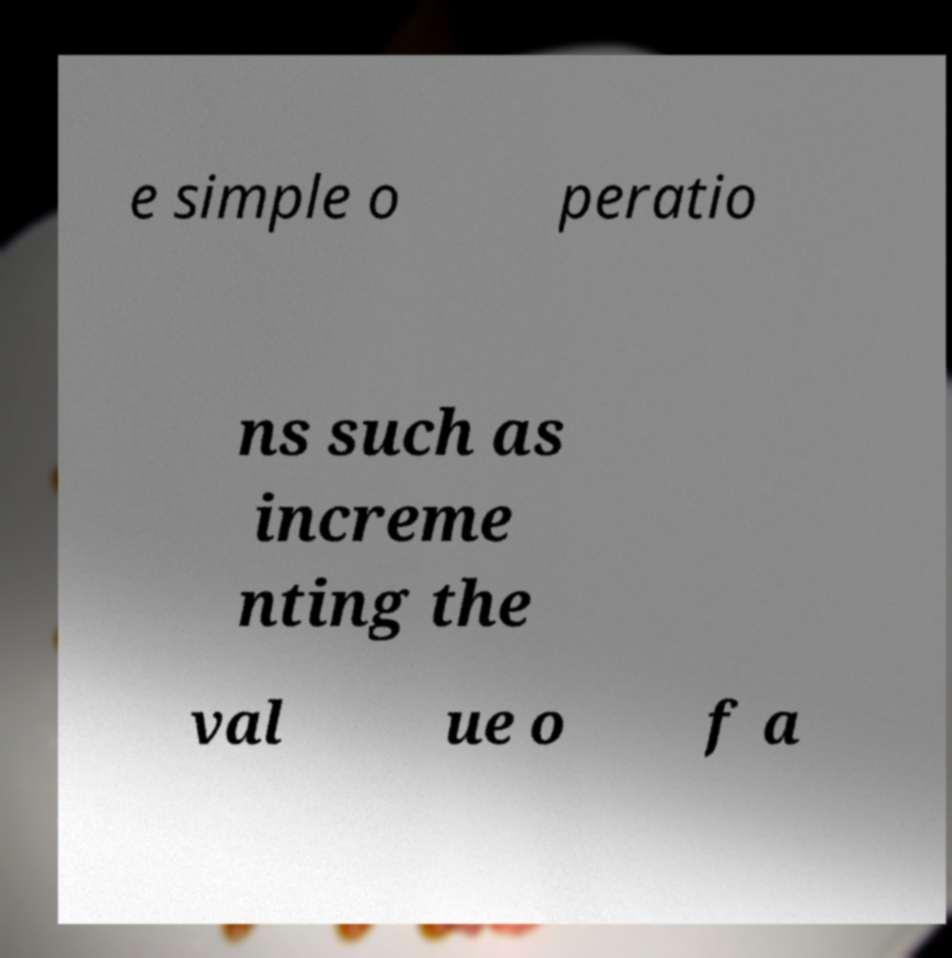There's text embedded in this image that I need extracted. Can you transcribe it verbatim? e simple o peratio ns such as increme nting the val ue o f a 